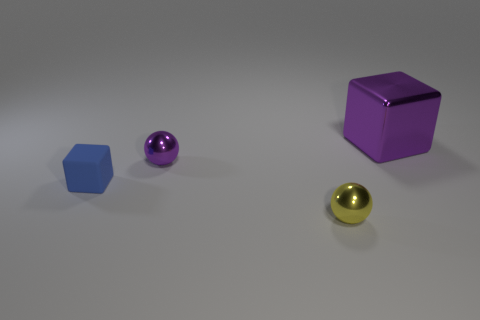Is the size of the blue cube the same as the purple metallic ball?
Give a very brief answer. Yes. The block that is the same material as the yellow object is what size?
Your response must be concise. Large. How many small things are the same color as the metal block?
Offer a terse response. 1. Is the number of tiny blue matte things behind the rubber block less than the number of tiny metallic things on the left side of the large metallic object?
Provide a short and direct response. Yes. Is the shape of the purple metal thing that is in front of the large object the same as  the yellow shiny thing?
Offer a terse response. Yes. Is there any other thing that is made of the same material as the tiny block?
Your answer should be very brief. No. Is the material of the ball that is behind the small blue rubber cube the same as the tiny yellow ball?
Offer a very short reply. Yes. What is the material of the object on the left side of the purple metallic object that is on the left side of the big purple object that is behind the small purple metal object?
Your answer should be very brief. Rubber. There is a block behind the blue matte object; what color is it?
Your response must be concise. Purple. There is a tiny thing behind the block that is left of the tiny purple metal object; what number of spheres are in front of it?
Your answer should be compact. 1. 